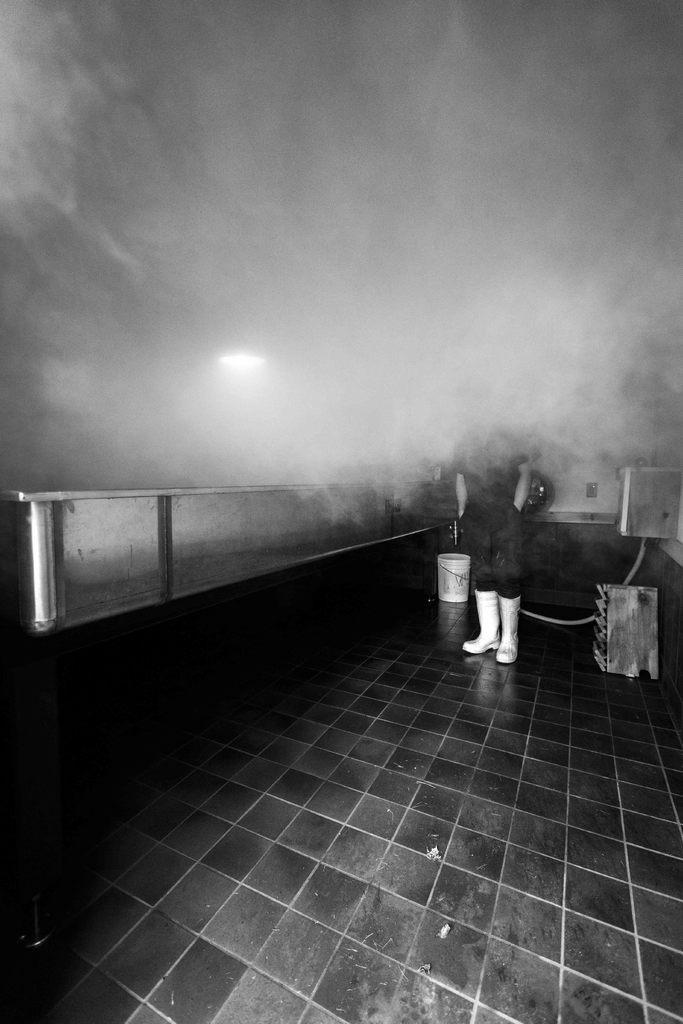How would you summarize this image in a sentence or two? In the picture I can see a person is standing and some other objects on the floor. This picture is black and white in color. 